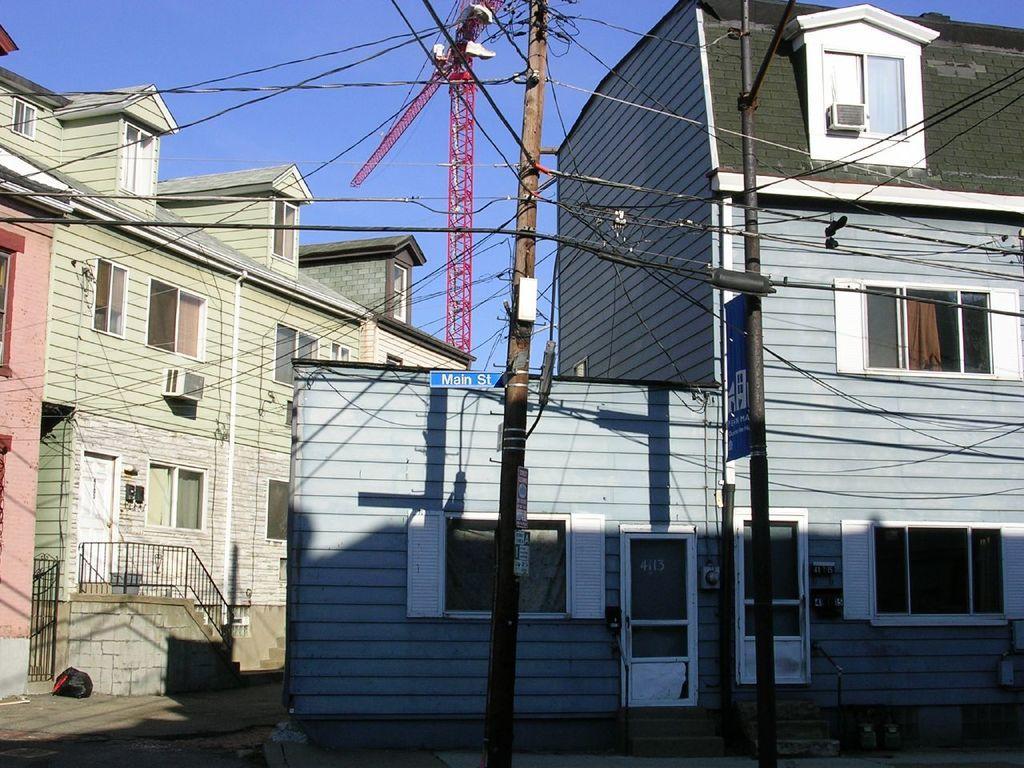Describe this image in one or two sentences. Here we can see buildings, railing, doors and windows. These are current polls, cables and boards. Sky is in blue color. 